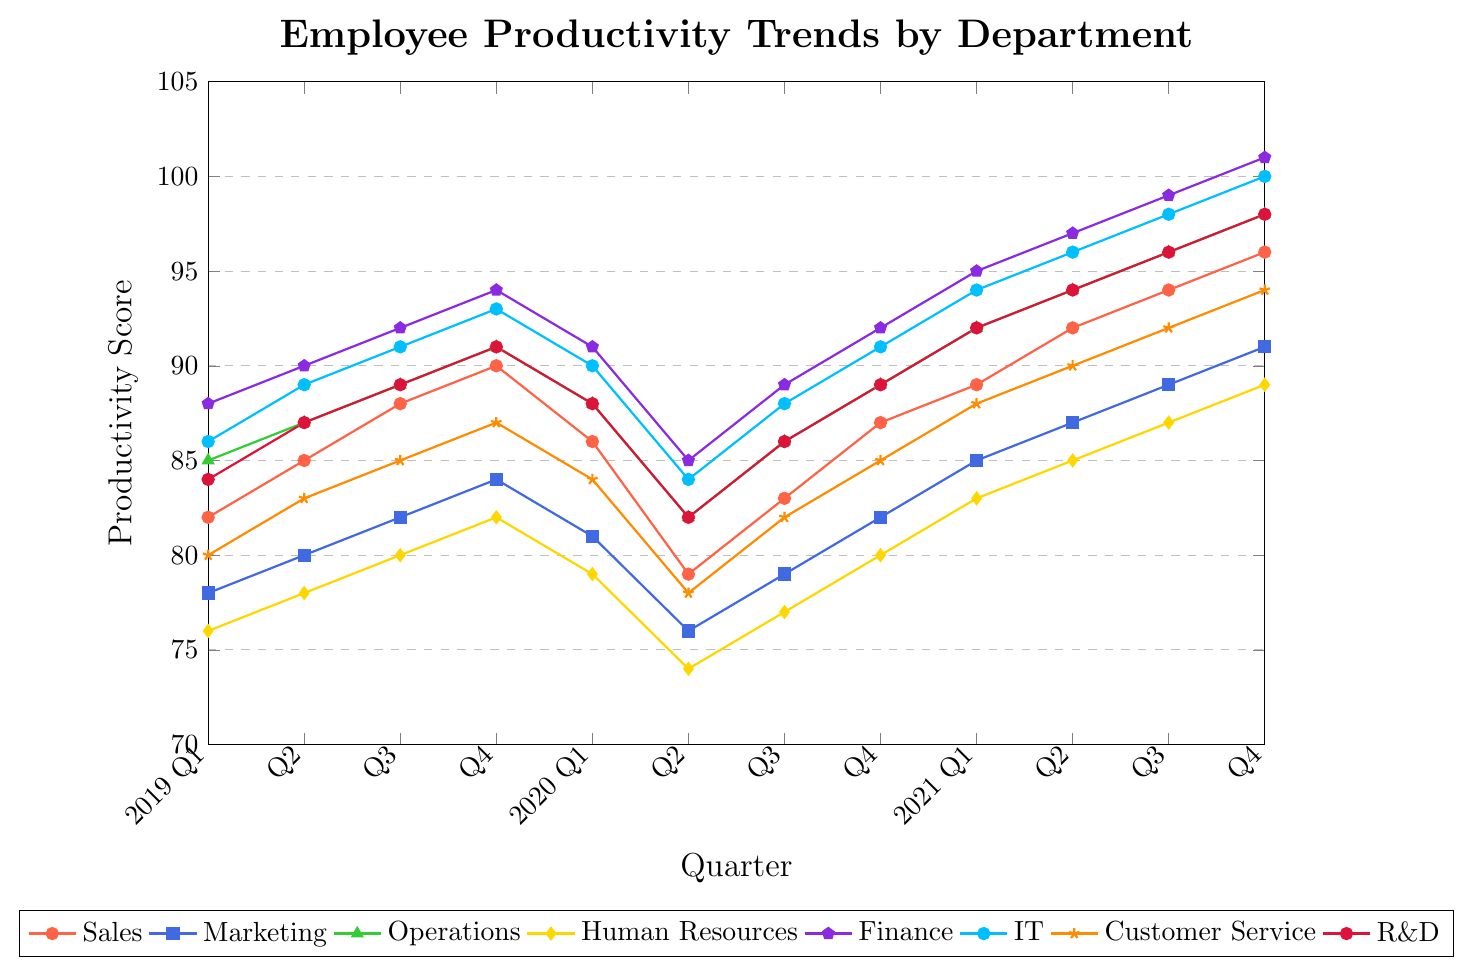Which department had the highest productivity score in 2021 Q4? In the figure, we see that the highest productivity score for any department in 2021 Q4 is 101, which belongs to Finance.
Answer: Finance How did the productivity score of the Sales department change from 2019 Q1 to 2020 Q2? The productivity score of the Sales department increased from 82 in 2019 Q1 to 90 in 2019 Q4 and then decreased to 79 in 2020 Q2. The net change is 79 - 82 = -3.
Answer: Decreased by 3 What is the average productivity score of the Marketing department in 2021? The productivity scores for the Marketing department in 2021 are 85, 87, 89, and 91. The average is (85 + 87 + 89 + 91)/4 = 88.
Answer: 88 Compare the productivity trend of the IT department between 2019 and 2021 The IT department’s productivity shows a general upward trend from 86 in 2019 Q1 to 100 in 2021 Q4, despite slight decreases in 2020 Q1 from 90 to 84.
Answer: Upward trend Which departments showed a drop in productivity between 2019 Q4 and 2020 Q2? By examining the figure, the Sales, Marketing, Operations, Human Resources, Finance, IT, Customer Service, and R&D departments all show a drop in productivity between these periods.
Answer: Sales, Marketing, Operations, Human Resources, Finance, IT, Customer Service, R&D Which department had the least variation in productivity score from 2019 Q1 to 2021 Q4? To determine the variation, we consider the range of scores for each department. Human Resources has the smallest range: from 74 to 89, a range of 15 points.
Answer: Human Resources What is the difference between the highest and lowest productivity scores of Operations in 2020? The highest productivity score in 2020 for Operations is 89 in Q4 and the lowest is 82 in Q2. The difference is 89 - 82 = 7.
Answer: 7 How did the productivity score of R&D change from 2020 Q2 to 2021 Q2? The productivity score of R&D increased from 82 in 2020 Q2 to 94 in 2021 Q2. The net change is 94 - 82 = 12.
Answer: Increased by 12 What were the highest and lowest productivity scores for the Customer Service department in 2021? The productivity scores for Customer Service in 2021 were 88, 90, 92, and 94. Thus, the highest score was 94 and the lowest was 88.
Answer: Highest: 94, Lowest: 88 